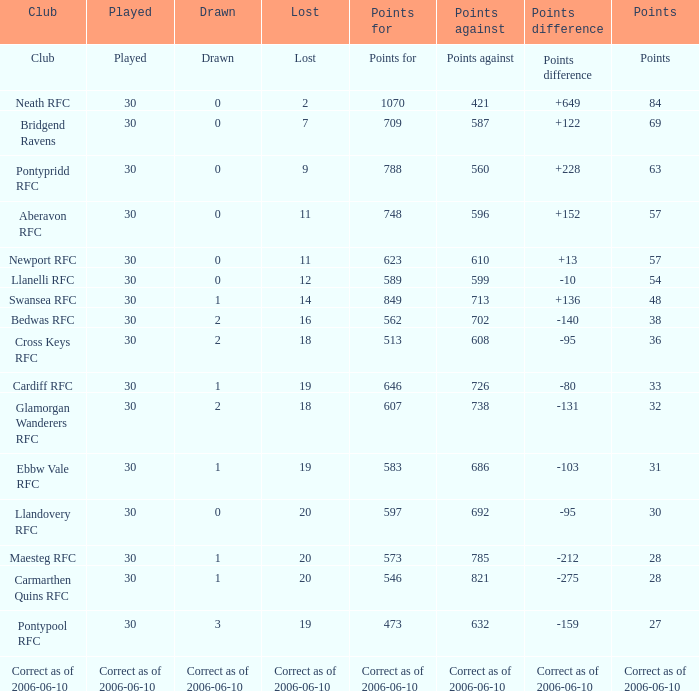What is points used for when the amount is "63"? 788.0. 